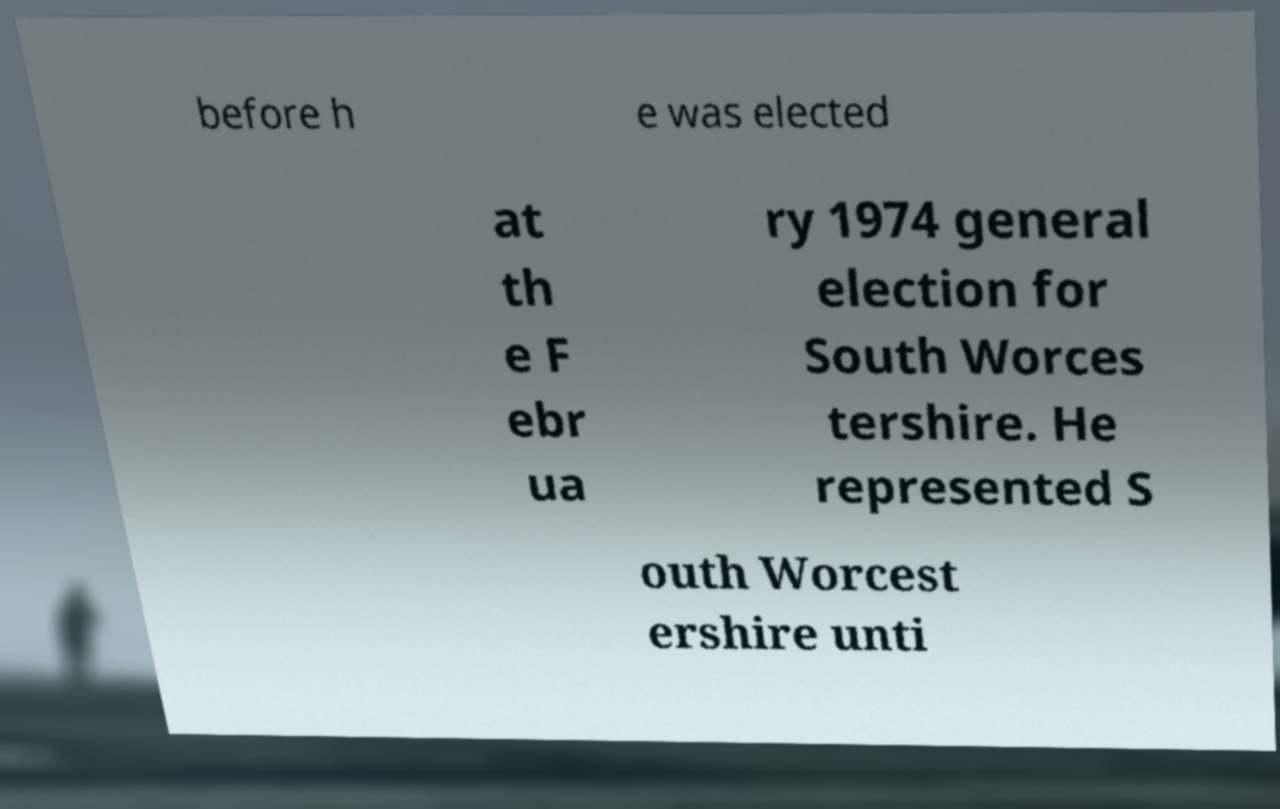Could you extract and type out the text from this image? before h e was elected at th e F ebr ua ry 1974 general election for South Worces tershire. He represented S outh Worcest ershire unti 